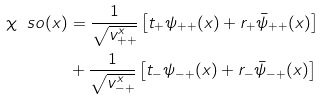<formula> <loc_0><loc_0><loc_500><loc_500>\chi _ { \ } s o ( x ) & = \frac { 1 } { \sqrt { v _ { + + } ^ { x } } } \left [ t _ { + } \psi _ { + + } ( x ) + r _ { + } \bar { \psi } _ { + + } ( x ) \right ] \\ & + \frac { 1 } { \sqrt { v _ { - + } ^ { x } } } \left [ t _ { - } \psi _ { - + } ( x ) + r _ { - } \bar { \psi } _ { - + } ( x ) \right ]</formula> 